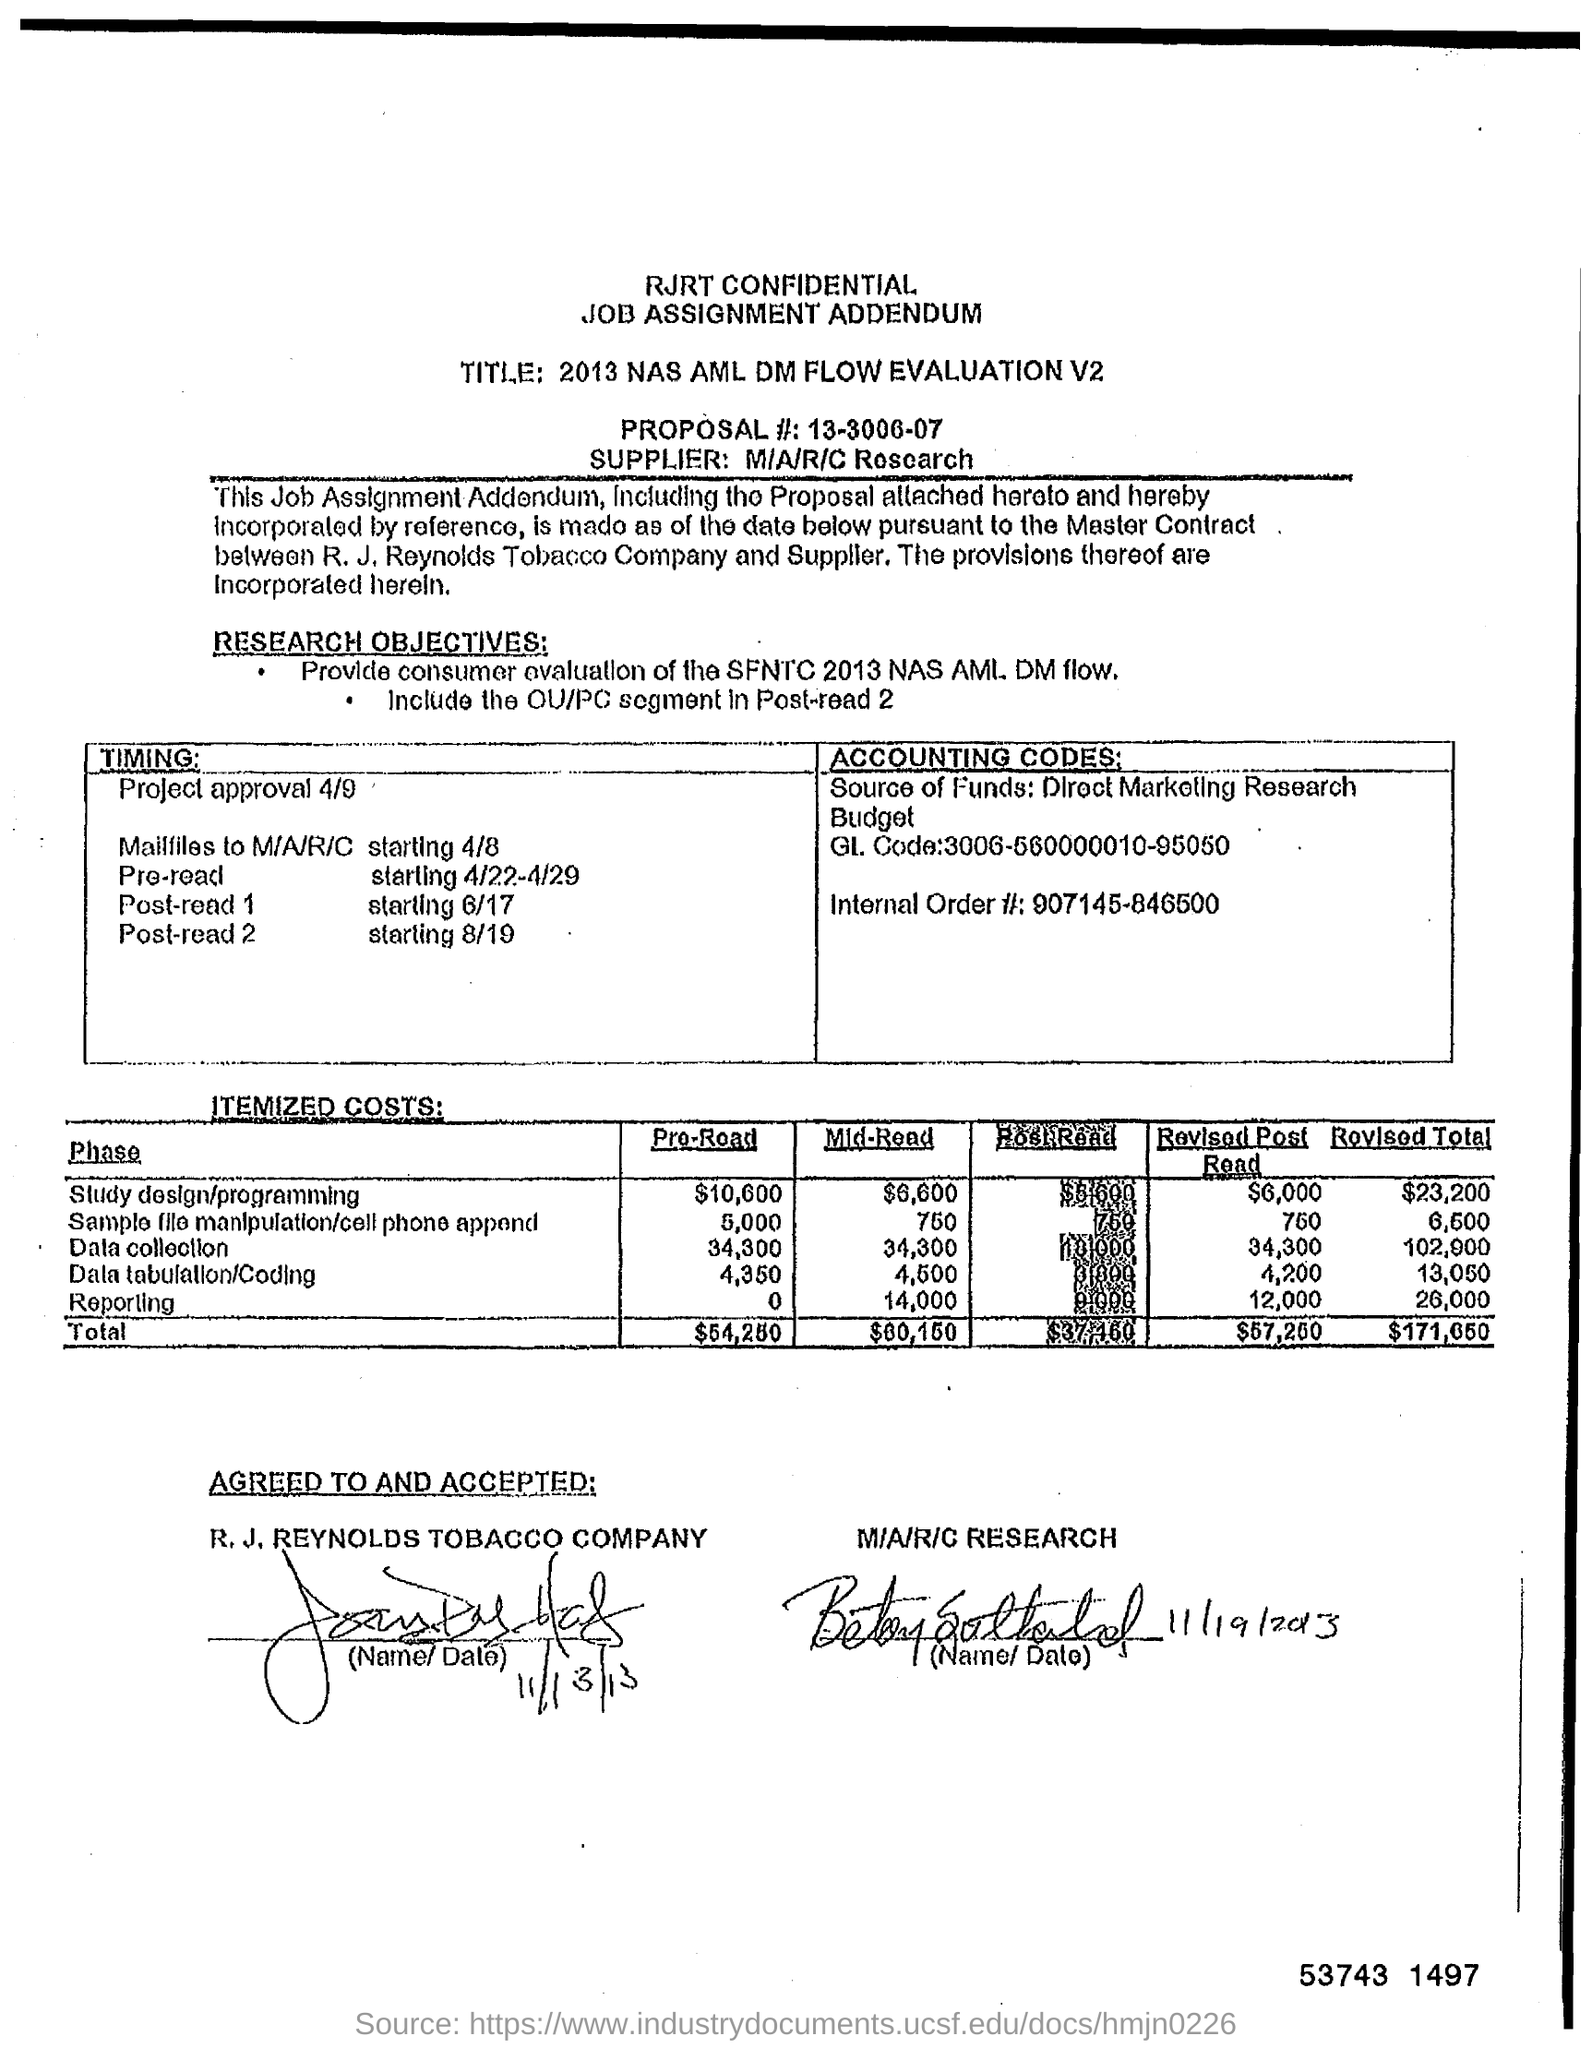Who is the supplier?
Your answer should be compact. M/A/R/C Research. What is the "Revised Total" for "Data Collection"?
Offer a very short reply. 102,900. What is the "Revised Total" for "Reporting"?
Your response must be concise. 26,000. 